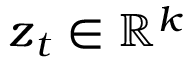Convert formula to latex. <formula><loc_0><loc_0><loc_500><loc_500>z _ { t } \in \mathbb { R } ^ { k }</formula> 